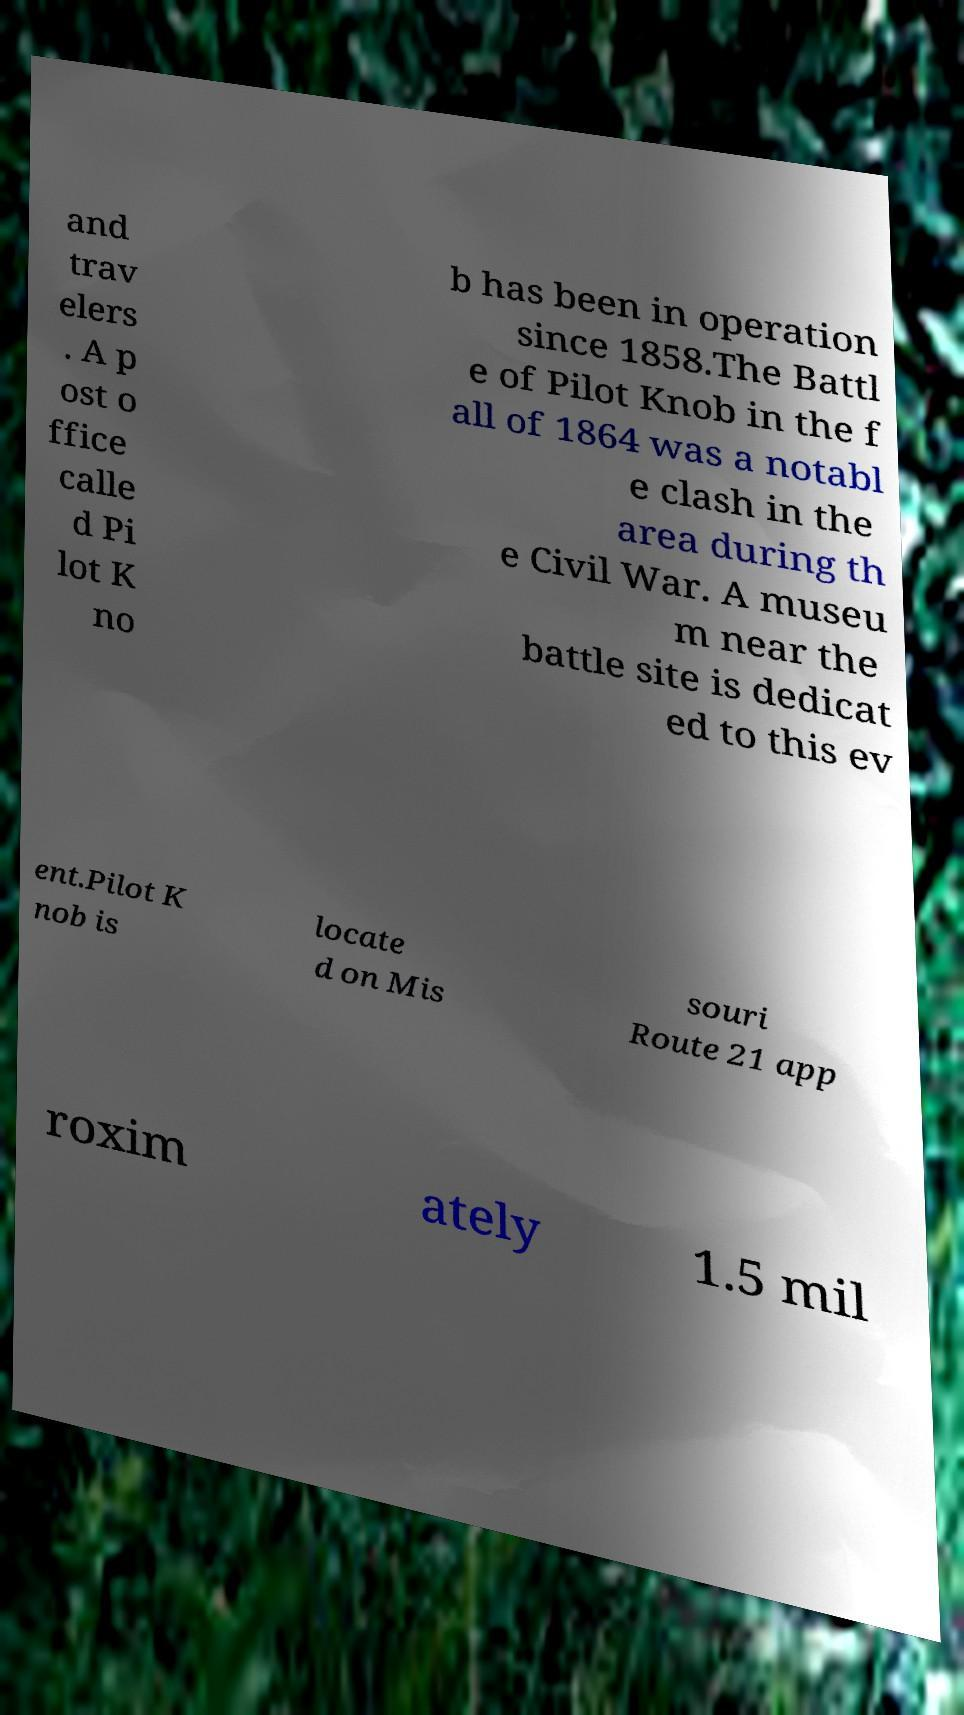For documentation purposes, I need the text within this image transcribed. Could you provide that? and trav elers . A p ost o ffice calle d Pi lot K no b has been in operation since 1858.The Battl e of Pilot Knob in the f all of 1864 was a notabl e clash in the area during th e Civil War. A museu m near the battle site is dedicat ed to this ev ent.Pilot K nob is locate d on Mis souri Route 21 app roxim ately 1.5 mil 